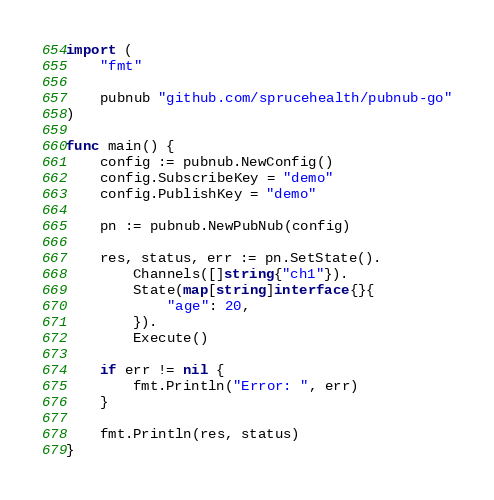Convert code to text. <code><loc_0><loc_0><loc_500><loc_500><_Go_>import (
	"fmt"

	pubnub "github.com/sprucehealth/pubnub-go"
)

func main() {
	config := pubnub.NewConfig()
	config.SubscribeKey = "demo"
	config.PublishKey = "demo"

	pn := pubnub.NewPubNub(config)

	res, status, err := pn.SetState().
		Channels([]string{"ch1"}).
		State(map[string]interface{}{
			"age": 20,
		}).
		Execute()

	if err != nil {
		fmt.Println("Error: ", err)
	}

	fmt.Println(res, status)
}
</code> 